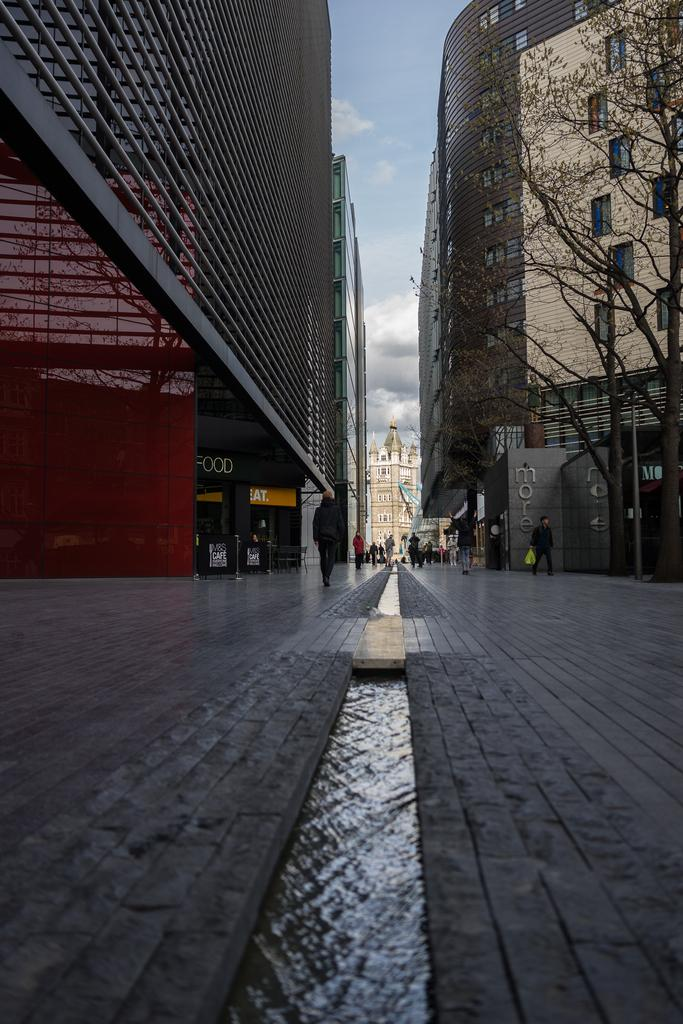<image>
Render a clear and concise summary of the photo. A narrow, brick city street that runs between two high rises has a stream of water running down its middle. 